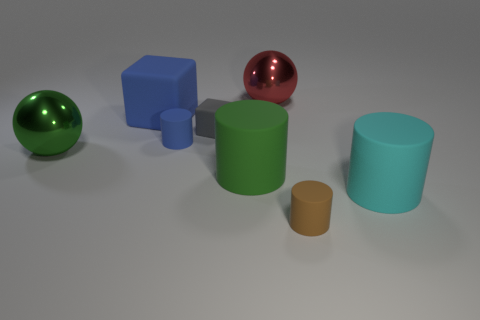There is a tiny object that is the same shape as the large blue thing; what color is it?
Offer a very short reply. Gray. What color is the large metal ball on the right side of the big ball that is left of the big blue object?
Provide a short and direct response. Red. What is the shape of the small brown matte object?
Give a very brief answer. Cylinder. There is a large thing that is both in front of the large blue object and to the left of the gray cube; what is its shape?
Make the answer very short. Sphere. There is a big cube that is made of the same material as the small cube; what is its color?
Ensure brevity in your answer.  Blue. There is a big object on the right side of the shiny object to the right of the large shiny thing in front of the big rubber block; what shape is it?
Your answer should be compact. Cylinder. The gray rubber cube has what size?
Keep it short and to the point. Small. The green object that is the same material as the large cyan object is what shape?
Offer a very short reply. Cylinder. Is the number of large cyan rubber things on the right side of the large green shiny ball less than the number of large green metallic objects?
Offer a terse response. No. There is a tiny rubber cylinder behind the large green ball; what is its color?
Give a very brief answer. Blue. 